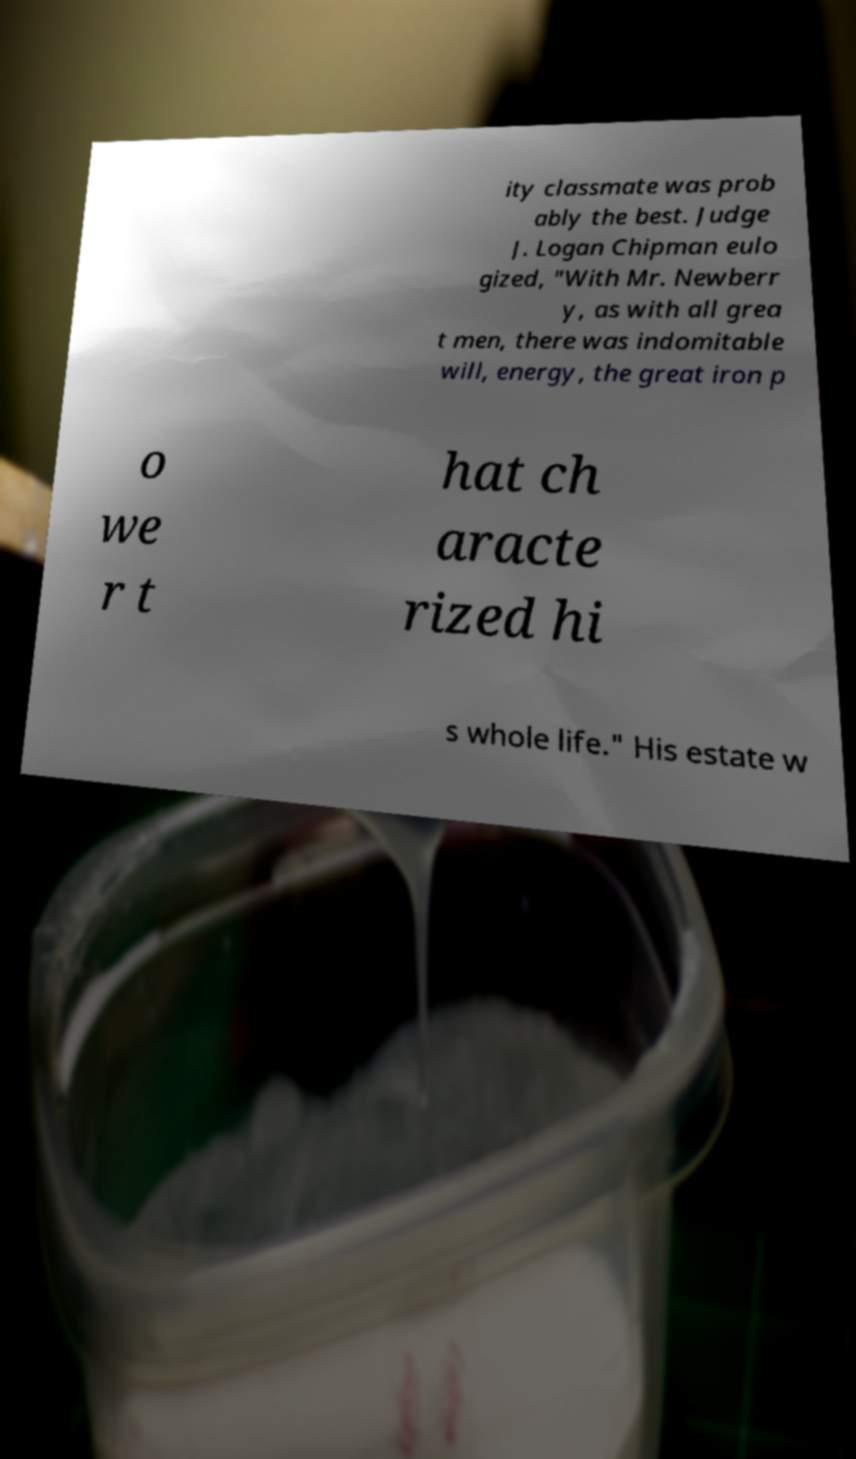For documentation purposes, I need the text within this image transcribed. Could you provide that? ity classmate was prob ably the best. Judge J. Logan Chipman eulo gized, "With Mr. Newberr y, as with all grea t men, there was indomitable will, energy, the great iron p o we r t hat ch aracte rized hi s whole life." His estate w 